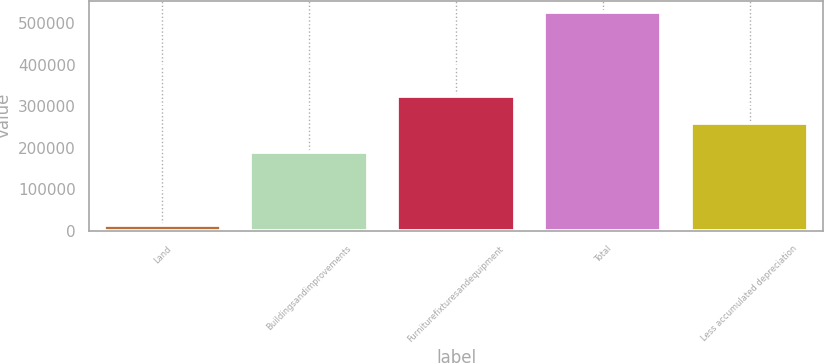Convert chart. <chart><loc_0><loc_0><loc_500><loc_500><bar_chart><fcel>Land<fcel>Buildingsandimprovements<fcel>Furniturefixturesandequipment<fcel>Total<fcel>Less accumulated depreciation<nl><fcel>14359<fcel>189367<fcel>323251<fcel>526977<fcel>259257<nl></chart> 